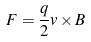Convert formula to latex. <formula><loc_0><loc_0><loc_500><loc_500>F = \frac { q } { 2 } v \times B</formula> 